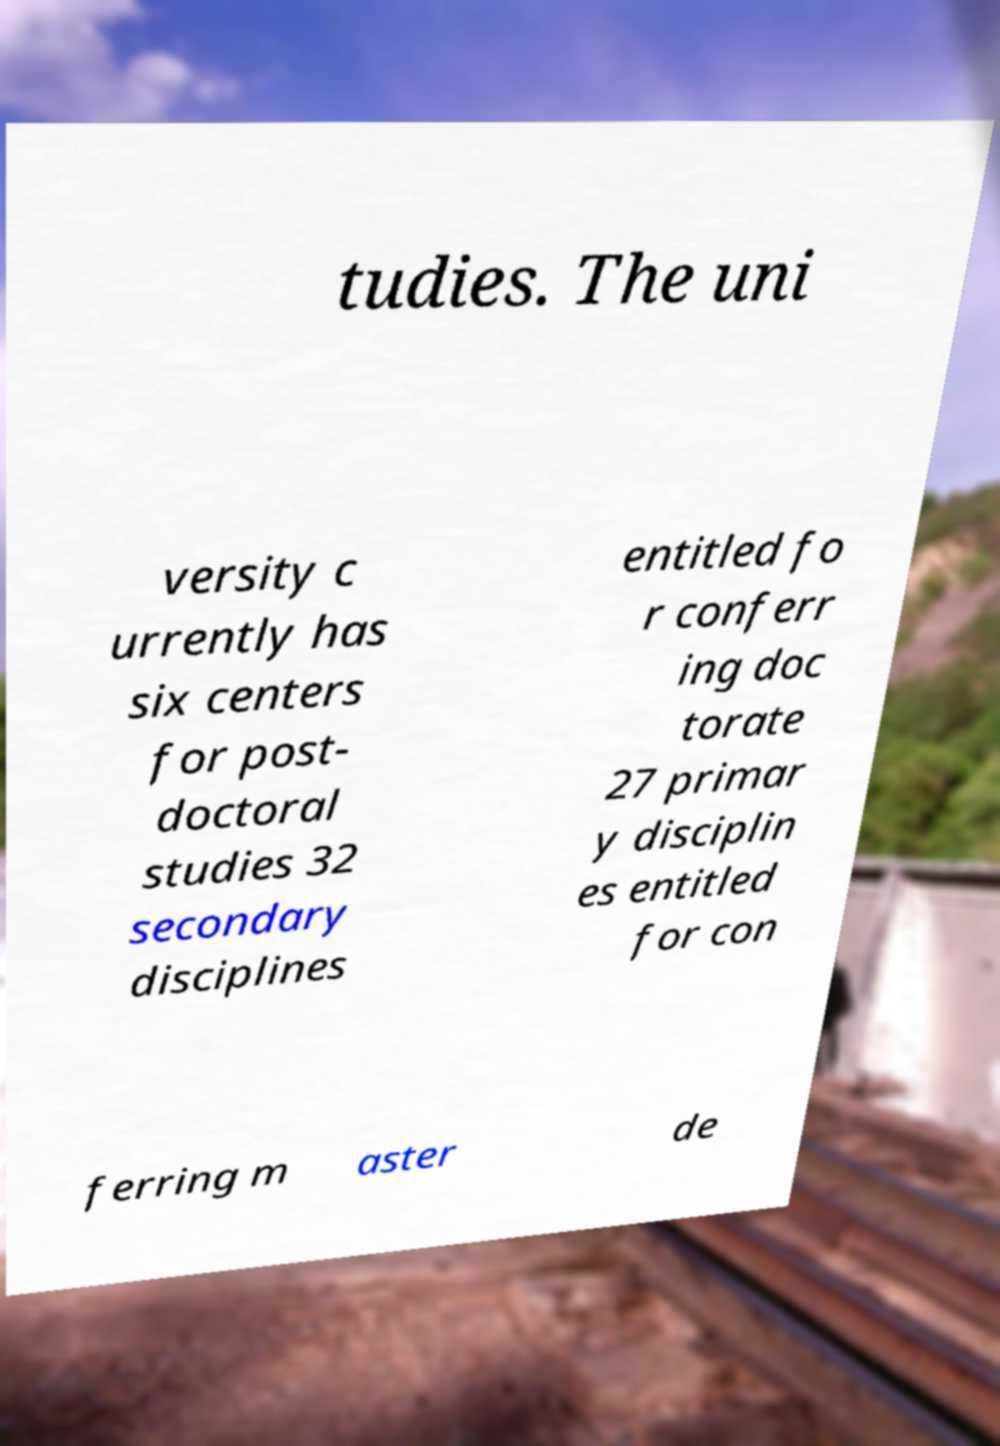I need the written content from this picture converted into text. Can you do that? tudies. The uni versity c urrently has six centers for post- doctoral studies 32 secondary disciplines entitled fo r conferr ing doc torate 27 primar y disciplin es entitled for con ferring m aster de 